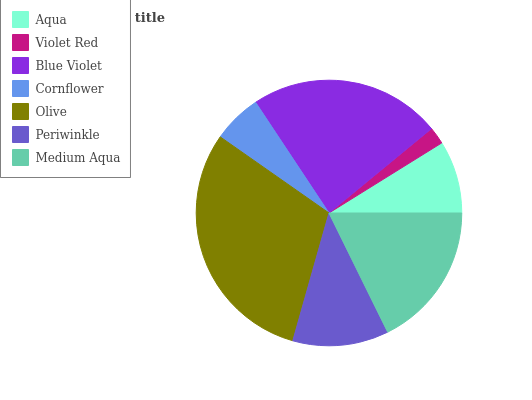Is Violet Red the minimum?
Answer yes or no. Yes. Is Olive the maximum?
Answer yes or no. Yes. Is Blue Violet the minimum?
Answer yes or no. No. Is Blue Violet the maximum?
Answer yes or no. No. Is Blue Violet greater than Violet Red?
Answer yes or no. Yes. Is Violet Red less than Blue Violet?
Answer yes or no. Yes. Is Violet Red greater than Blue Violet?
Answer yes or no. No. Is Blue Violet less than Violet Red?
Answer yes or no. No. Is Periwinkle the high median?
Answer yes or no. Yes. Is Periwinkle the low median?
Answer yes or no. Yes. Is Blue Violet the high median?
Answer yes or no. No. Is Aqua the low median?
Answer yes or no. No. 